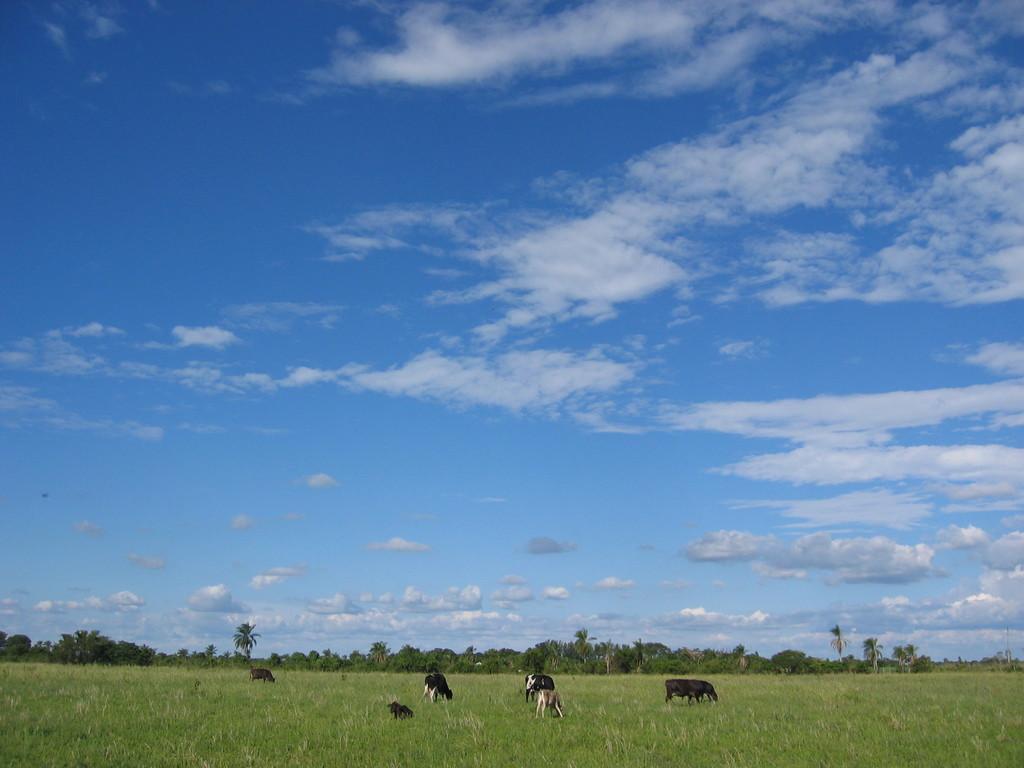Please provide a concise description of this image. In front of the image there are cows. At the bottom of the image there is grass on the surface. In the background of the image there are trees. At the top of the image there are clouds in the sky. 